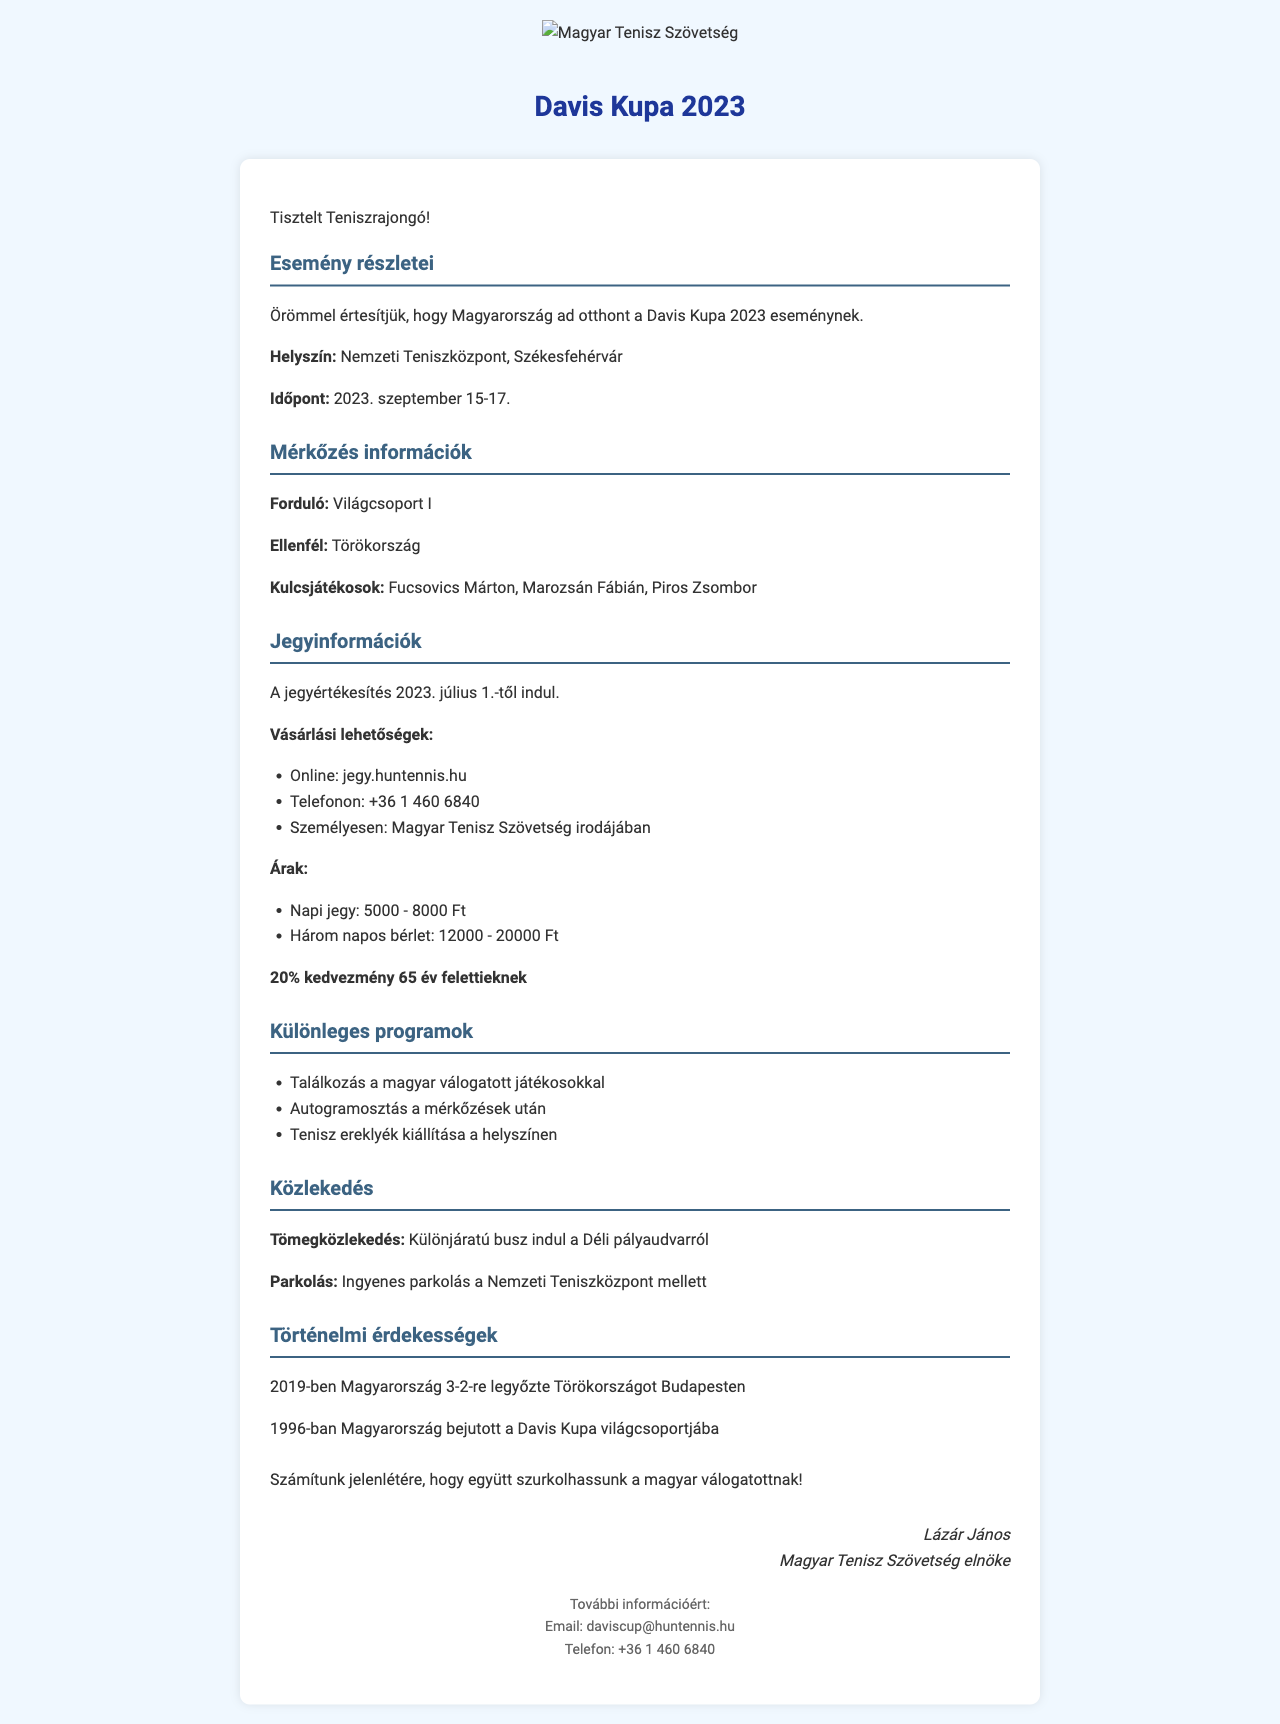What is the event name? The event name is mentioned prominently at the top of the document.
Answer: Davis Kupa 2023 Where is the event being held? The venue for the event is specified in the details section.
Answer: Nemzeti Teniszközpont, Székesfehérvár What are the dates of the event? The date range for the event is provided in the introduction.
Answer: 2023. szeptember 15-17 Who is the opponent in the matches? The opponent team is listed under the match details section.
Answer: Törökország What is the senior discount percentage? The document states the discount available for seniors.
Answer: 20% When does ticket sales start? The start date for ticket sales is indicated in the ticket information section.
Answer: 2023. július 1 What is the price range for a daily ticket? The price range is explicitly mentioned in the ticket information section.
Answer: 5000 - 8000 Ft What special feature includes meeting with players? A specific program feature mentions meeting the players.
Answer: Találkozás a magyar válogatott játékosokkal What historical fact is noted about Hungary's last match with Turkey? This information relates to a past encounter provided in the historical context section.
Answer: 2019-ben Magyarország 3-2-re legyőzte Törökországot Budapesten 